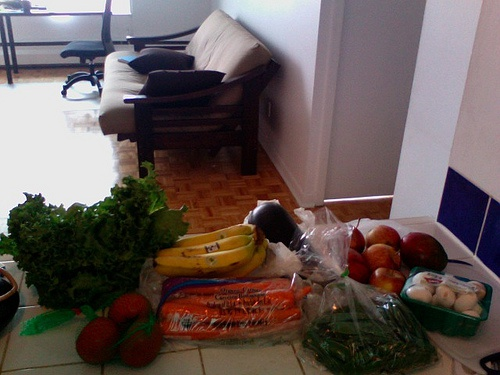Describe the objects in this image and their specific colors. I can see dining table in white, black, maroon, and gray tones, couch in white, black, darkgray, lightgray, and gray tones, broccoli in white, black, darkgreen, and gray tones, bowl in white, black, gray, and maroon tones, and banana in white, olive, maroon, and black tones in this image. 